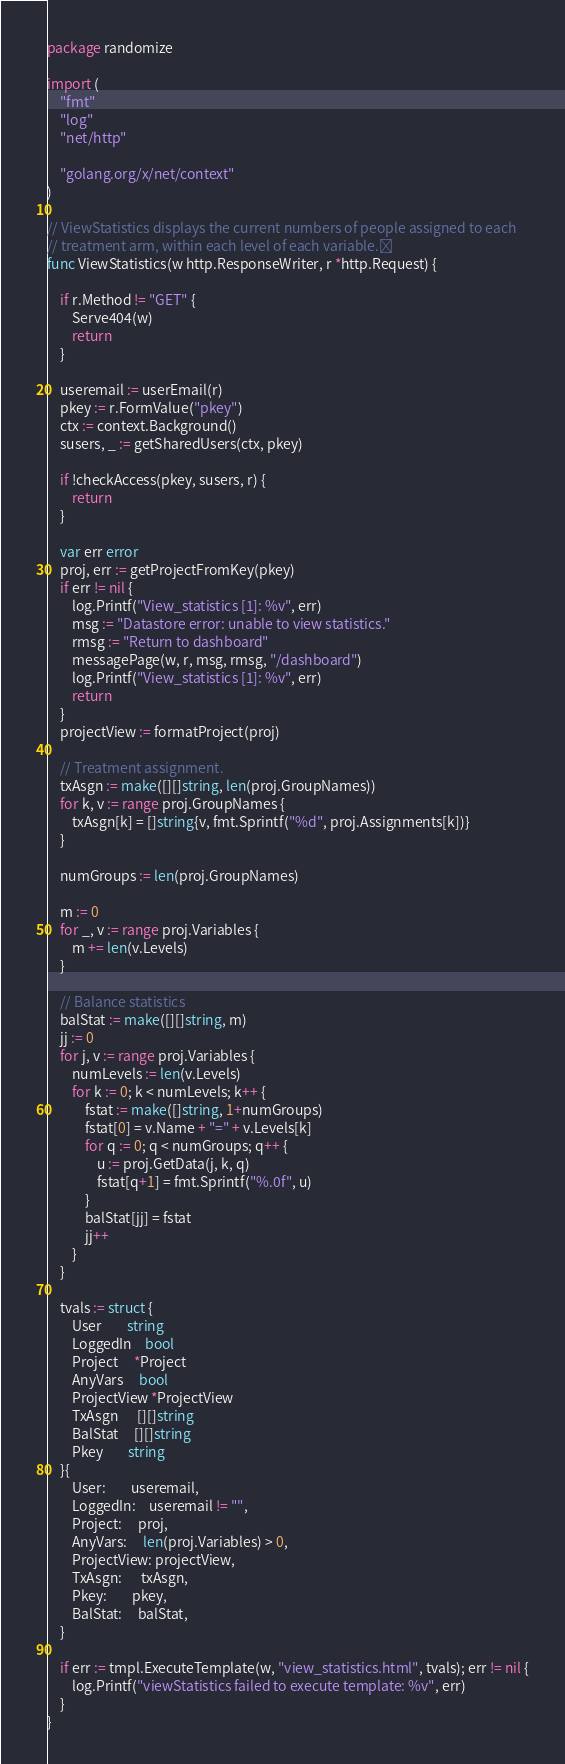Convert code to text. <code><loc_0><loc_0><loc_500><loc_500><_Go_>package randomize

import (
	"fmt"
	"log"
	"net/http"

	"golang.org/x/net/context"
)

// ViewStatistics displays the current numbers of people assigned to each
// treatment arm, within each level of each variable.
func ViewStatistics(w http.ResponseWriter, r *http.Request) {

	if r.Method != "GET" {
		Serve404(w)
		return
	}

	useremail := userEmail(r)
	pkey := r.FormValue("pkey")
	ctx := context.Background()
	susers, _ := getSharedUsers(ctx, pkey)

	if !checkAccess(pkey, susers, r) {
		return
	}

	var err error
	proj, err := getProjectFromKey(pkey)
	if err != nil {
		log.Printf("View_statistics [1]: %v", err)
		msg := "Datastore error: unable to view statistics."
		rmsg := "Return to dashboard"
		messagePage(w, r, msg, rmsg, "/dashboard")
		log.Printf("View_statistics [1]: %v", err)
		return
	}
	projectView := formatProject(proj)

	// Treatment assignment.
	txAsgn := make([][]string, len(proj.GroupNames))
	for k, v := range proj.GroupNames {
		txAsgn[k] = []string{v, fmt.Sprintf("%d", proj.Assignments[k])}
	}

	numGroups := len(proj.GroupNames)

	m := 0
	for _, v := range proj.Variables {
		m += len(v.Levels)
	}

	// Balance statistics
	balStat := make([][]string, m)
	jj := 0
	for j, v := range proj.Variables {
		numLevels := len(v.Levels)
		for k := 0; k < numLevels; k++ {
			fstat := make([]string, 1+numGroups)
			fstat[0] = v.Name + "=" + v.Levels[k]
			for q := 0; q < numGroups; q++ {
				u := proj.GetData(j, k, q)
				fstat[q+1] = fmt.Sprintf("%.0f", u)
			}
			balStat[jj] = fstat
			jj++
		}
	}

	tvals := struct {
		User        string
		LoggedIn    bool
		Project     *Project
		AnyVars     bool
		ProjectView *ProjectView
		TxAsgn      [][]string
		BalStat     [][]string
		Pkey        string
	}{
		User:        useremail,
		LoggedIn:    useremail != "",
		Project:     proj,
		AnyVars:     len(proj.Variables) > 0,
		ProjectView: projectView,
		TxAsgn:      txAsgn,
		Pkey:        pkey,
		BalStat:     balStat,
	}

	if err := tmpl.ExecuteTemplate(w, "view_statistics.html", tvals); err != nil {
		log.Printf("viewStatistics failed to execute template: %v", err)
	}
}
</code> 